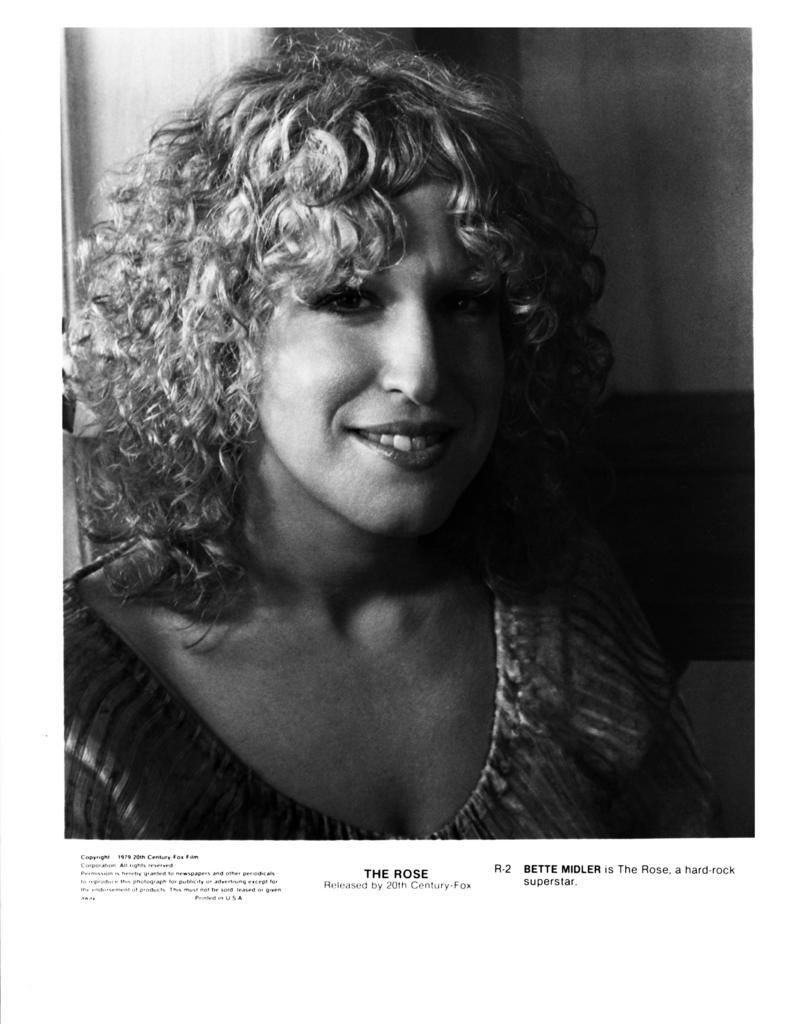What is the color scheme of the image? The image is black and white. Can you describe the main subject of the image? There is a woman in the image. Is there any text present in the image? Yes, there is text at the bottom of the image. How many ladybugs can be seen on the woman's stomach in the image? There are no ladybugs present in the image, and the woman's stomach is not visible. 